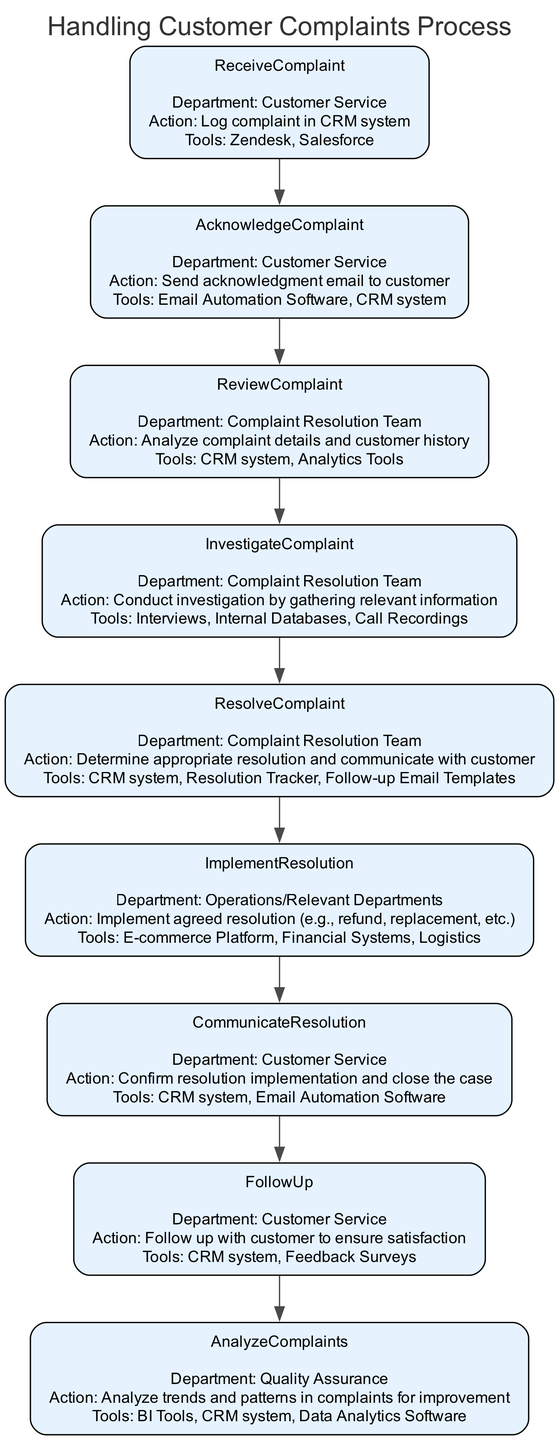What department is responsible for acknowledging complaints? The "AcknowledgeComplaint" node in the diagram indicates that the Customer Service department is responsible for sending acknowledgment emails to customers.
Answer: Customer Service What follows after the "ReceiveComplaint" step? The flow of the diagram shows a direct connection from "ReceiveComplaint" to "AcknowledgeComplaint," meaning acknowledging the complaint immediately follows receiving it.
Answer: AcknowledgeComplaint How many tools are mentioned in the "ResolveComplaint" step? In the "ResolveComplaint" node, it lists three tools: CRM system, Resolution Tracker, and Follow-up Email Templates. Therefore, the total number of tools mentioned is three.
Answer: Three Which team investigates complaints? Referring to the "InvestigateComplaint" node, it is clear that the "Complaint Resolution Team" is responsible for conducting investigations by gathering relevant information.
Answer: Complaint Resolution Team What action occurs after confirming the resolution implementation? Following the "CommunicateResolution" step, the next action is "FollowUp," which indicates that the process continues with following up with the customer to ensure satisfaction after confirming the resolution.
Answer: FollowUp What is the primary action taken in the "ImplementResolution" step? The "ImplementResolution" node specifies that the primary action is to implement the agreed resolution, such as a refund or replacement, which is a crucial part of the complaint resolution process.
Answer: Implement agreed resolution What tools are used in the "AnalyzeComplaints" step? According to the "AnalyzeComplaints" node, the tools utilized include BI Tools, CRM system, and Data Analytics Software, which assist in analyzing trends and patterns in complaints.
Answer: BI Tools, CRM system, Data Analytics Software How many steps are in the complaint handling process? By reviewing the flow chart, we note that there are eight distinct steps represented, indicating that the handling process consists of eight specific stages.
Answer: Eight What comes immediately after the "InvestigateComplaint" step? The diagram shows a direct flow from "InvestigateComplaint" to "ResolveComplaint." This indicates that after investigating, the next step is resolving the complaint.
Answer: ResolveComplaint 